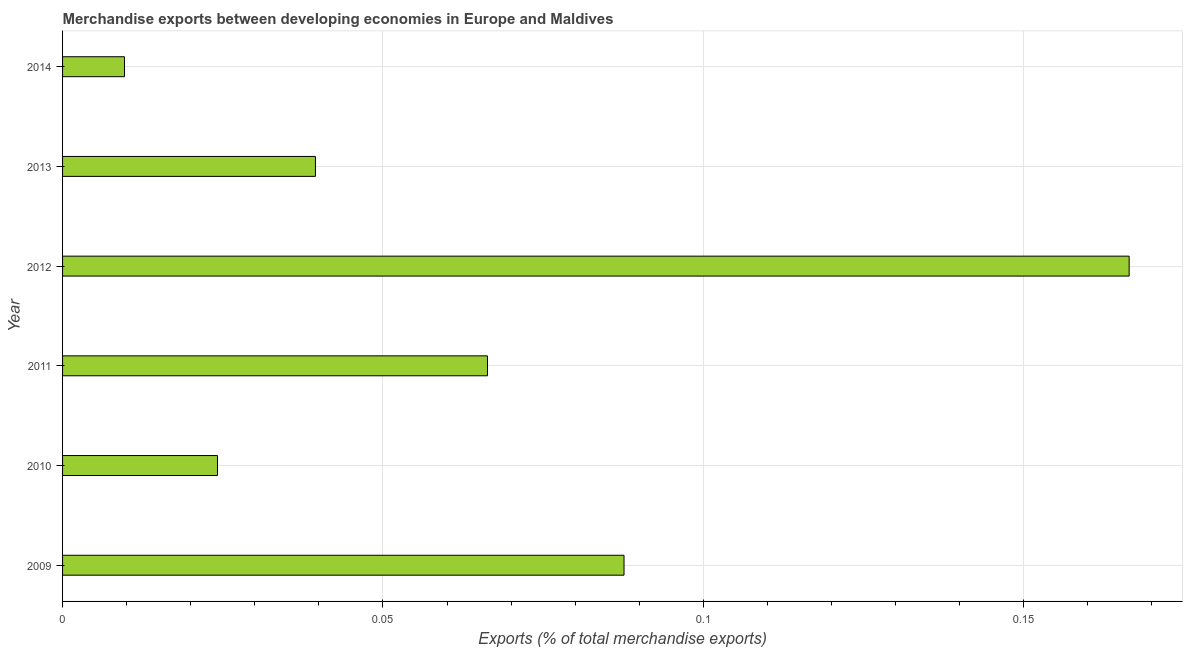Does the graph contain any zero values?
Give a very brief answer. No. Does the graph contain grids?
Your answer should be very brief. Yes. What is the title of the graph?
Your answer should be compact. Merchandise exports between developing economies in Europe and Maldives. What is the label or title of the X-axis?
Your answer should be very brief. Exports (% of total merchandise exports). What is the label or title of the Y-axis?
Your answer should be very brief. Year. What is the merchandise exports in 2009?
Give a very brief answer. 0.09. Across all years, what is the maximum merchandise exports?
Make the answer very short. 0.17. Across all years, what is the minimum merchandise exports?
Your response must be concise. 0.01. In which year was the merchandise exports minimum?
Give a very brief answer. 2014. What is the sum of the merchandise exports?
Provide a succinct answer. 0.39. What is the difference between the merchandise exports in 2010 and 2013?
Offer a terse response. -0.01. What is the average merchandise exports per year?
Give a very brief answer. 0.07. What is the median merchandise exports?
Offer a very short reply. 0.05. In how many years, is the merchandise exports greater than 0.06 %?
Keep it short and to the point. 3. Do a majority of the years between 2014 and 2013 (inclusive) have merchandise exports greater than 0.01 %?
Provide a succinct answer. No. What is the ratio of the merchandise exports in 2009 to that in 2010?
Your answer should be very brief. 3.62. Is the difference between the merchandise exports in 2009 and 2012 greater than the difference between any two years?
Provide a succinct answer. No. What is the difference between the highest and the second highest merchandise exports?
Provide a succinct answer. 0.08. What is the difference between the highest and the lowest merchandise exports?
Your answer should be very brief. 0.16. How many bars are there?
Provide a succinct answer. 6. How many years are there in the graph?
Make the answer very short. 6. What is the difference between two consecutive major ticks on the X-axis?
Your answer should be compact. 0.05. What is the Exports (% of total merchandise exports) in 2009?
Provide a succinct answer. 0.09. What is the Exports (% of total merchandise exports) in 2010?
Make the answer very short. 0.02. What is the Exports (% of total merchandise exports) of 2011?
Offer a very short reply. 0.07. What is the Exports (% of total merchandise exports) of 2012?
Provide a succinct answer. 0.17. What is the Exports (% of total merchandise exports) of 2013?
Make the answer very short. 0.04. What is the Exports (% of total merchandise exports) in 2014?
Keep it short and to the point. 0.01. What is the difference between the Exports (% of total merchandise exports) in 2009 and 2010?
Your answer should be very brief. 0.06. What is the difference between the Exports (% of total merchandise exports) in 2009 and 2011?
Offer a terse response. 0.02. What is the difference between the Exports (% of total merchandise exports) in 2009 and 2012?
Ensure brevity in your answer.  -0.08. What is the difference between the Exports (% of total merchandise exports) in 2009 and 2013?
Offer a very short reply. 0.05. What is the difference between the Exports (% of total merchandise exports) in 2009 and 2014?
Keep it short and to the point. 0.08. What is the difference between the Exports (% of total merchandise exports) in 2010 and 2011?
Provide a short and direct response. -0.04. What is the difference between the Exports (% of total merchandise exports) in 2010 and 2012?
Provide a succinct answer. -0.14. What is the difference between the Exports (% of total merchandise exports) in 2010 and 2013?
Offer a terse response. -0.02. What is the difference between the Exports (% of total merchandise exports) in 2010 and 2014?
Offer a terse response. 0.01. What is the difference between the Exports (% of total merchandise exports) in 2011 and 2012?
Give a very brief answer. -0.1. What is the difference between the Exports (% of total merchandise exports) in 2011 and 2013?
Ensure brevity in your answer.  0.03. What is the difference between the Exports (% of total merchandise exports) in 2011 and 2014?
Your answer should be very brief. 0.06. What is the difference between the Exports (% of total merchandise exports) in 2012 and 2013?
Keep it short and to the point. 0.13. What is the difference between the Exports (% of total merchandise exports) in 2012 and 2014?
Give a very brief answer. 0.16. What is the difference between the Exports (% of total merchandise exports) in 2013 and 2014?
Ensure brevity in your answer.  0.03. What is the ratio of the Exports (% of total merchandise exports) in 2009 to that in 2010?
Offer a very short reply. 3.62. What is the ratio of the Exports (% of total merchandise exports) in 2009 to that in 2011?
Keep it short and to the point. 1.32. What is the ratio of the Exports (% of total merchandise exports) in 2009 to that in 2012?
Provide a succinct answer. 0.53. What is the ratio of the Exports (% of total merchandise exports) in 2009 to that in 2013?
Ensure brevity in your answer.  2.22. What is the ratio of the Exports (% of total merchandise exports) in 2009 to that in 2014?
Your response must be concise. 9.06. What is the ratio of the Exports (% of total merchandise exports) in 2010 to that in 2011?
Your answer should be compact. 0.36. What is the ratio of the Exports (% of total merchandise exports) in 2010 to that in 2012?
Your answer should be very brief. 0.14. What is the ratio of the Exports (% of total merchandise exports) in 2010 to that in 2013?
Provide a succinct answer. 0.61. What is the ratio of the Exports (% of total merchandise exports) in 2010 to that in 2014?
Keep it short and to the point. 2.5. What is the ratio of the Exports (% of total merchandise exports) in 2011 to that in 2012?
Make the answer very short. 0.4. What is the ratio of the Exports (% of total merchandise exports) in 2011 to that in 2013?
Provide a succinct answer. 1.68. What is the ratio of the Exports (% of total merchandise exports) in 2011 to that in 2014?
Provide a short and direct response. 6.86. What is the ratio of the Exports (% of total merchandise exports) in 2012 to that in 2013?
Your answer should be compact. 4.22. What is the ratio of the Exports (% of total merchandise exports) in 2012 to that in 2014?
Your response must be concise. 17.22. What is the ratio of the Exports (% of total merchandise exports) in 2013 to that in 2014?
Provide a short and direct response. 4.08. 